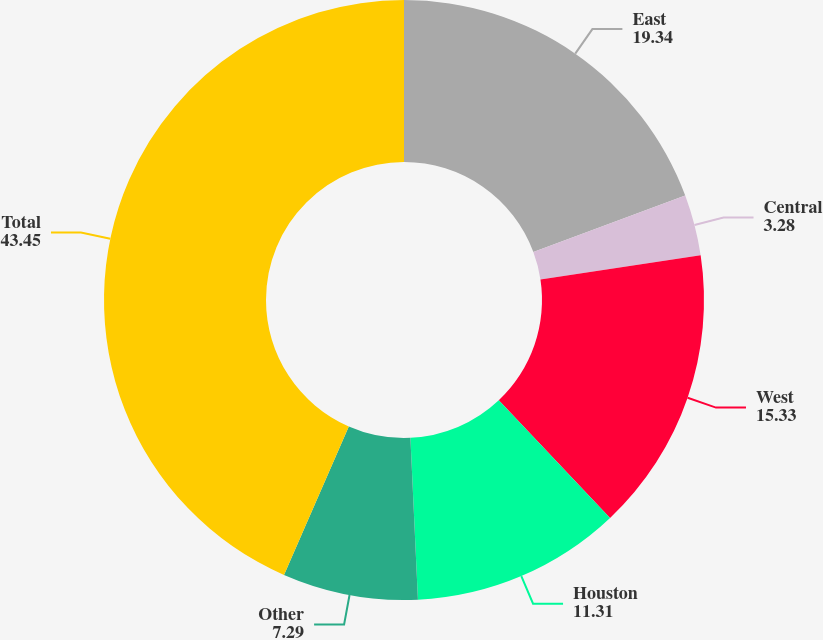Convert chart to OTSL. <chart><loc_0><loc_0><loc_500><loc_500><pie_chart><fcel>East<fcel>Central<fcel>West<fcel>Houston<fcel>Other<fcel>Total<nl><fcel>19.34%<fcel>3.28%<fcel>15.33%<fcel>11.31%<fcel>7.29%<fcel>43.45%<nl></chart> 